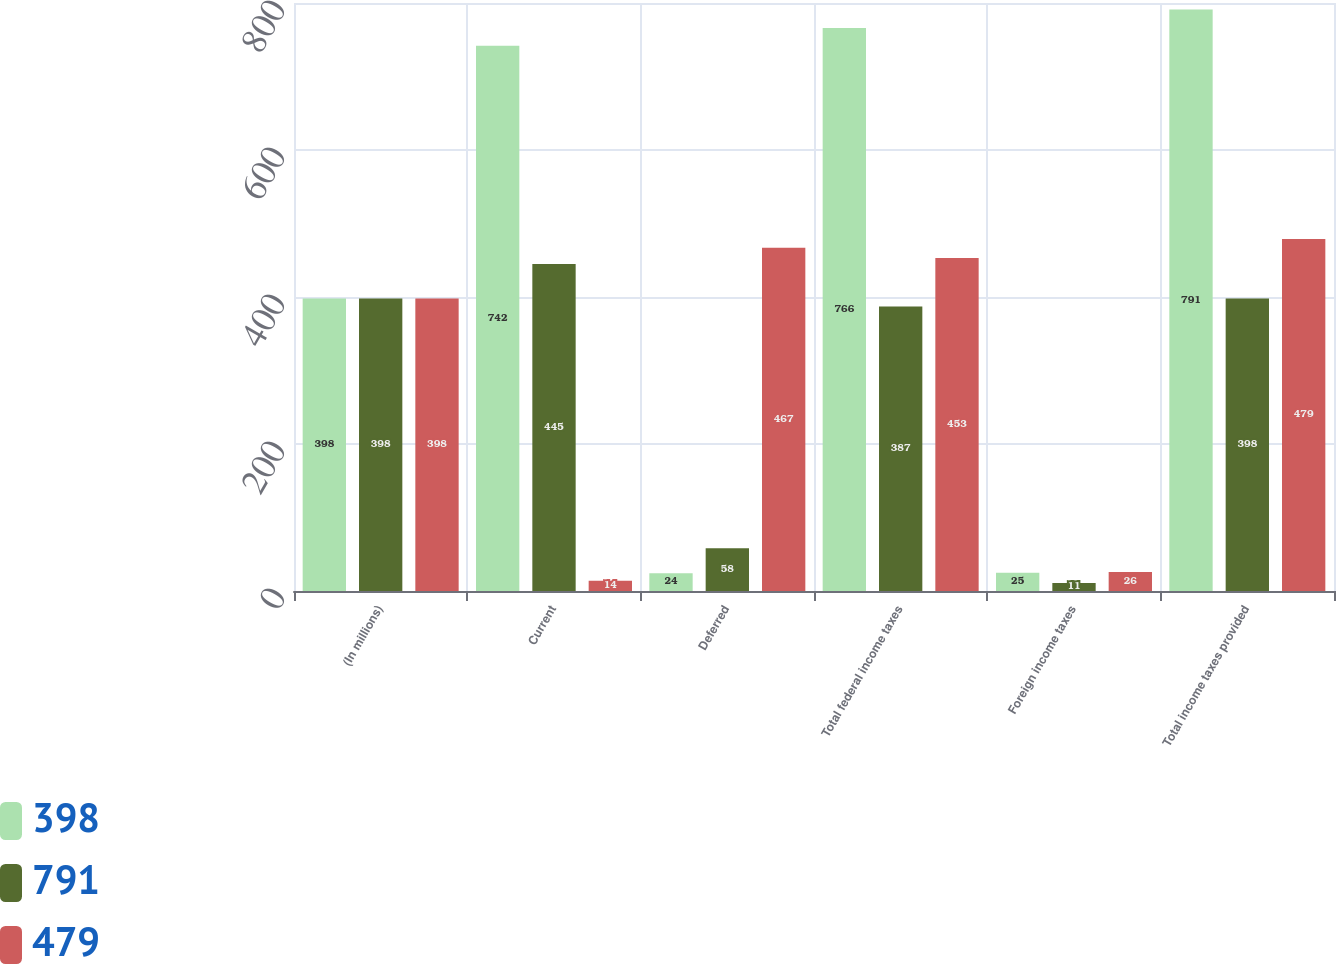<chart> <loc_0><loc_0><loc_500><loc_500><stacked_bar_chart><ecel><fcel>(In millions)<fcel>Current<fcel>Deferred<fcel>Total federal income taxes<fcel>Foreign income taxes<fcel>Total income taxes provided<nl><fcel>398<fcel>398<fcel>742<fcel>24<fcel>766<fcel>25<fcel>791<nl><fcel>791<fcel>398<fcel>445<fcel>58<fcel>387<fcel>11<fcel>398<nl><fcel>479<fcel>398<fcel>14<fcel>467<fcel>453<fcel>26<fcel>479<nl></chart> 